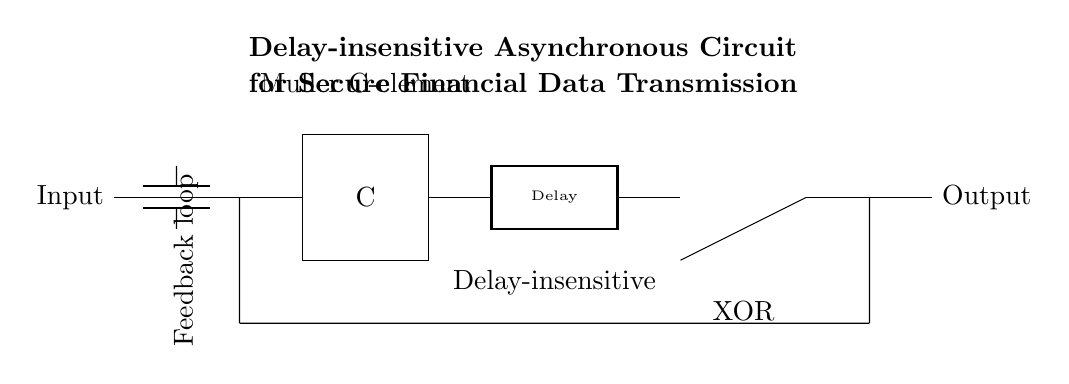What is the type of circuit shown? The circuit is an asynchronous circuit, which is indicated in the title, and is characterized by the lack of a global clock signal to synchronize changes in state.
Answer: Asynchronous What component is responsible for maintaining the state of the circuit? The Muller C-element maintains the state of the circuit by ensuring that the output only changes under certain conditions of its inputs, providing functionality essential for asynchronous operation.
Answer: Muller C-element What does the feedback loop do in this circuit? The feedback loop allows for the output to influence the input, enabling the circuit to maintain its state and thus create stable operation in response to input changes. This is crucial in asynchronous designs to manage sequential logic without a clock.
Answer: Maintain state Which component is used for generating a delay in the circuit? The rectangle labeled "Delay" represents the delay element in the circuit, which introduces timing adjustments necessary for the operation of asynchronous circuits to handle signal propagation properly.
Answer: Delay What is the purpose of the XOR gate in the circuit? The XOR gate processes two input signals to determine if they are different, outputting a high signal only when exactly one of the inputs is high, which is essential for decision-making in data transmission.
Answer: Decision-making What type of transmission does this circuit facilitate? The circuit is designed for secure financial data transmission, as indicated in the title, which emphasizes the protection and integrity of sensitive financial information during transfer.
Answer: Secure financial data Why is this circuit considered delay-insensitive? This circuit is labeled "Delay-insensitive" because its performance does not rely on precise timing relationships between input changes and outputs, which is a key feature of asynchronous designs facilitating robustness against variations in signal propagation times.
Answer: Robustness against timing 